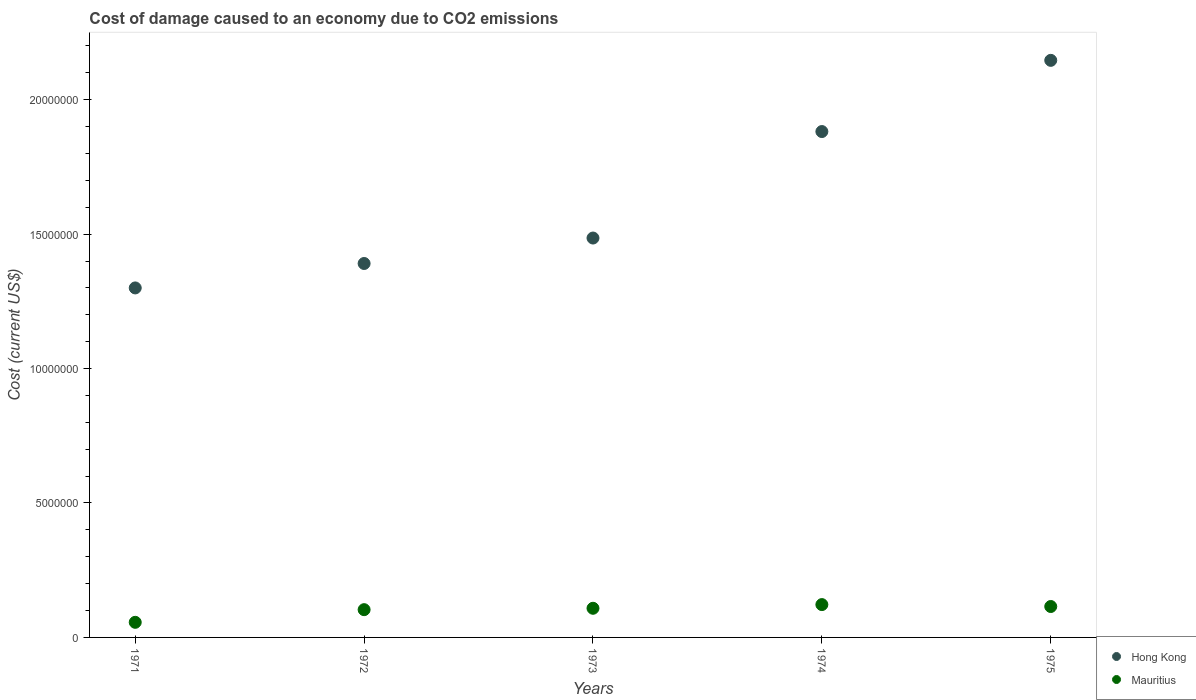Is the number of dotlines equal to the number of legend labels?
Your answer should be very brief. Yes. What is the cost of damage caused due to CO2 emissisons in Mauritius in 1975?
Offer a terse response. 1.15e+06. Across all years, what is the maximum cost of damage caused due to CO2 emissisons in Mauritius?
Make the answer very short. 1.22e+06. Across all years, what is the minimum cost of damage caused due to CO2 emissisons in Mauritius?
Ensure brevity in your answer.  5.62e+05. In which year was the cost of damage caused due to CO2 emissisons in Hong Kong maximum?
Provide a succinct answer. 1975. In which year was the cost of damage caused due to CO2 emissisons in Mauritius minimum?
Ensure brevity in your answer.  1971. What is the total cost of damage caused due to CO2 emissisons in Mauritius in the graph?
Your answer should be very brief. 5.05e+06. What is the difference between the cost of damage caused due to CO2 emissisons in Mauritius in 1973 and that in 1975?
Your answer should be compact. -6.59e+04. What is the difference between the cost of damage caused due to CO2 emissisons in Hong Kong in 1975 and the cost of damage caused due to CO2 emissisons in Mauritius in 1974?
Provide a succinct answer. 2.02e+07. What is the average cost of damage caused due to CO2 emissisons in Mauritius per year?
Your answer should be very brief. 1.01e+06. In the year 1972, what is the difference between the cost of damage caused due to CO2 emissisons in Hong Kong and cost of damage caused due to CO2 emissisons in Mauritius?
Your answer should be compact. 1.29e+07. What is the ratio of the cost of damage caused due to CO2 emissisons in Hong Kong in 1971 to that in 1972?
Give a very brief answer. 0.93. Is the cost of damage caused due to CO2 emissisons in Mauritius in 1972 less than that in 1973?
Ensure brevity in your answer.  Yes. What is the difference between the highest and the second highest cost of damage caused due to CO2 emissisons in Mauritius?
Ensure brevity in your answer.  7.12e+04. What is the difference between the highest and the lowest cost of damage caused due to CO2 emissisons in Mauritius?
Provide a succinct answer. 6.59e+05. Is the sum of the cost of damage caused due to CO2 emissisons in Hong Kong in 1972 and 1974 greater than the maximum cost of damage caused due to CO2 emissisons in Mauritius across all years?
Your response must be concise. Yes. Does the cost of damage caused due to CO2 emissisons in Mauritius monotonically increase over the years?
Your answer should be very brief. No. Is the cost of damage caused due to CO2 emissisons in Hong Kong strictly greater than the cost of damage caused due to CO2 emissisons in Mauritius over the years?
Provide a succinct answer. Yes. How many dotlines are there?
Keep it short and to the point. 2. What is the difference between two consecutive major ticks on the Y-axis?
Provide a short and direct response. 5.00e+06. Are the values on the major ticks of Y-axis written in scientific E-notation?
Offer a very short reply. No. Does the graph contain grids?
Your answer should be compact. No. Where does the legend appear in the graph?
Keep it short and to the point. Bottom right. How many legend labels are there?
Provide a short and direct response. 2. What is the title of the graph?
Offer a very short reply. Cost of damage caused to an economy due to CO2 emissions. Does "Australia" appear as one of the legend labels in the graph?
Provide a succinct answer. No. What is the label or title of the Y-axis?
Offer a terse response. Cost (current US$). What is the Cost (current US$) of Hong Kong in 1971?
Offer a terse response. 1.30e+07. What is the Cost (current US$) in Mauritius in 1971?
Ensure brevity in your answer.  5.62e+05. What is the Cost (current US$) of Hong Kong in 1972?
Keep it short and to the point. 1.39e+07. What is the Cost (current US$) in Mauritius in 1972?
Offer a terse response. 1.03e+06. What is the Cost (current US$) in Hong Kong in 1973?
Keep it short and to the point. 1.49e+07. What is the Cost (current US$) of Mauritius in 1973?
Make the answer very short. 1.08e+06. What is the Cost (current US$) of Hong Kong in 1974?
Ensure brevity in your answer.  1.88e+07. What is the Cost (current US$) of Mauritius in 1974?
Ensure brevity in your answer.  1.22e+06. What is the Cost (current US$) of Hong Kong in 1975?
Your answer should be very brief. 2.15e+07. What is the Cost (current US$) in Mauritius in 1975?
Offer a terse response. 1.15e+06. Across all years, what is the maximum Cost (current US$) of Hong Kong?
Offer a very short reply. 2.15e+07. Across all years, what is the maximum Cost (current US$) in Mauritius?
Your response must be concise. 1.22e+06. Across all years, what is the minimum Cost (current US$) of Hong Kong?
Provide a short and direct response. 1.30e+07. Across all years, what is the minimum Cost (current US$) in Mauritius?
Keep it short and to the point. 5.62e+05. What is the total Cost (current US$) of Hong Kong in the graph?
Your response must be concise. 8.20e+07. What is the total Cost (current US$) in Mauritius in the graph?
Offer a terse response. 5.05e+06. What is the difference between the Cost (current US$) of Hong Kong in 1971 and that in 1972?
Give a very brief answer. -9.09e+05. What is the difference between the Cost (current US$) in Mauritius in 1971 and that in 1972?
Your answer should be very brief. -4.71e+05. What is the difference between the Cost (current US$) of Hong Kong in 1971 and that in 1973?
Make the answer very short. -1.86e+06. What is the difference between the Cost (current US$) in Mauritius in 1971 and that in 1973?
Your response must be concise. -5.22e+05. What is the difference between the Cost (current US$) in Hong Kong in 1971 and that in 1974?
Provide a short and direct response. -5.82e+06. What is the difference between the Cost (current US$) of Mauritius in 1971 and that in 1974?
Offer a terse response. -6.59e+05. What is the difference between the Cost (current US$) of Hong Kong in 1971 and that in 1975?
Offer a very short reply. -8.46e+06. What is the difference between the Cost (current US$) of Mauritius in 1971 and that in 1975?
Keep it short and to the point. -5.88e+05. What is the difference between the Cost (current US$) of Hong Kong in 1972 and that in 1973?
Your answer should be very brief. -9.47e+05. What is the difference between the Cost (current US$) in Mauritius in 1972 and that in 1973?
Offer a terse response. -5.14e+04. What is the difference between the Cost (current US$) of Hong Kong in 1972 and that in 1974?
Your answer should be very brief. -4.91e+06. What is the difference between the Cost (current US$) of Mauritius in 1972 and that in 1974?
Provide a short and direct response. -1.89e+05. What is the difference between the Cost (current US$) of Hong Kong in 1972 and that in 1975?
Provide a succinct answer. -7.56e+06. What is the difference between the Cost (current US$) of Mauritius in 1972 and that in 1975?
Offer a very short reply. -1.17e+05. What is the difference between the Cost (current US$) of Hong Kong in 1973 and that in 1974?
Provide a short and direct response. -3.96e+06. What is the difference between the Cost (current US$) of Mauritius in 1973 and that in 1974?
Offer a very short reply. -1.37e+05. What is the difference between the Cost (current US$) in Hong Kong in 1973 and that in 1975?
Give a very brief answer. -6.61e+06. What is the difference between the Cost (current US$) in Mauritius in 1973 and that in 1975?
Your answer should be very brief. -6.59e+04. What is the difference between the Cost (current US$) of Hong Kong in 1974 and that in 1975?
Keep it short and to the point. -2.65e+06. What is the difference between the Cost (current US$) of Mauritius in 1974 and that in 1975?
Keep it short and to the point. 7.12e+04. What is the difference between the Cost (current US$) of Hong Kong in 1971 and the Cost (current US$) of Mauritius in 1972?
Offer a terse response. 1.20e+07. What is the difference between the Cost (current US$) of Hong Kong in 1971 and the Cost (current US$) of Mauritius in 1973?
Provide a short and direct response. 1.19e+07. What is the difference between the Cost (current US$) in Hong Kong in 1971 and the Cost (current US$) in Mauritius in 1974?
Your answer should be compact. 1.18e+07. What is the difference between the Cost (current US$) of Hong Kong in 1971 and the Cost (current US$) of Mauritius in 1975?
Keep it short and to the point. 1.18e+07. What is the difference between the Cost (current US$) of Hong Kong in 1972 and the Cost (current US$) of Mauritius in 1973?
Keep it short and to the point. 1.28e+07. What is the difference between the Cost (current US$) in Hong Kong in 1972 and the Cost (current US$) in Mauritius in 1974?
Keep it short and to the point. 1.27e+07. What is the difference between the Cost (current US$) of Hong Kong in 1972 and the Cost (current US$) of Mauritius in 1975?
Offer a terse response. 1.28e+07. What is the difference between the Cost (current US$) in Hong Kong in 1973 and the Cost (current US$) in Mauritius in 1974?
Your answer should be compact. 1.36e+07. What is the difference between the Cost (current US$) of Hong Kong in 1973 and the Cost (current US$) of Mauritius in 1975?
Offer a terse response. 1.37e+07. What is the difference between the Cost (current US$) of Hong Kong in 1974 and the Cost (current US$) of Mauritius in 1975?
Offer a very short reply. 1.77e+07. What is the average Cost (current US$) of Hong Kong per year?
Give a very brief answer. 1.64e+07. What is the average Cost (current US$) in Mauritius per year?
Ensure brevity in your answer.  1.01e+06. In the year 1971, what is the difference between the Cost (current US$) in Hong Kong and Cost (current US$) in Mauritius?
Offer a very short reply. 1.24e+07. In the year 1972, what is the difference between the Cost (current US$) of Hong Kong and Cost (current US$) of Mauritius?
Provide a short and direct response. 1.29e+07. In the year 1973, what is the difference between the Cost (current US$) in Hong Kong and Cost (current US$) in Mauritius?
Provide a short and direct response. 1.38e+07. In the year 1974, what is the difference between the Cost (current US$) of Hong Kong and Cost (current US$) of Mauritius?
Ensure brevity in your answer.  1.76e+07. In the year 1975, what is the difference between the Cost (current US$) in Hong Kong and Cost (current US$) in Mauritius?
Give a very brief answer. 2.03e+07. What is the ratio of the Cost (current US$) in Hong Kong in 1971 to that in 1972?
Give a very brief answer. 0.93. What is the ratio of the Cost (current US$) of Mauritius in 1971 to that in 1972?
Provide a short and direct response. 0.54. What is the ratio of the Cost (current US$) in Hong Kong in 1971 to that in 1973?
Give a very brief answer. 0.88. What is the ratio of the Cost (current US$) of Mauritius in 1971 to that in 1973?
Your response must be concise. 0.52. What is the ratio of the Cost (current US$) of Hong Kong in 1971 to that in 1974?
Offer a very short reply. 0.69. What is the ratio of the Cost (current US$) of Mauritius in 1971 to that in 1974?
Offer a terse response. 0.46. What is the ratio of the Cost (current US$) of Hong Kong in 1971 to that in 1975?
Make the answer very short. 0.61. What is the ratio of the Cost (current US$) of Mauritius in 1971 to that in 1975?
Offer a terse response. 0.49. What is the ratio of the Cost (current US$) in Hong Kong in 1972 to that in 1973?
Offer a terse response. 0.94. What is the ratio of the Cost (current US$) of Mauritius in 1972 to that in 1973?
Keep it short and to the point. 0.95. What is the ratio of the Cost (current US$) in Hong Kong in 1972 to that in 1974?
Ensure brevity in your answer.  0.74. What is the ratio of the Cost (current US$) in Mauritius in 1972 to that in 1974?
Offer a very short reply. 0.85. What is the ratio of the Cost (current US$) in Hong Kong in 1972 to that in 1975?
Offer a very short reply. 0.65. What is the ratio of the Cost (current US$) of Mauritius in 1972 to that in 1975?
Offer a terse response. 0.9. What is the ratio of the Cost (current US$) of Hong Kong in 1973 to that in 1974?
Your answer should be compact. 0.79. What is the ratio of the Cost (current US$) of Mauritius in 1973 to that in 1974?
Make the answer very short. 0.89. What is the ratio of the Cost (current US$) in Hong Kong in 1973 to that in 1975?
Your answer should be compact. 0.69. What is the ratio of the Cost (current US$) of Mauritius in 1973 to that in 1975?
Provide a short and direct response. 0.94. What is the ratio of the Cost (current US$) of Hong Kong in 1974 to that in 1975?
Keep it short and to the point. 0.88. What is the ratio of the Cost (current US$) of Mauritius in 1974 to that in 1975?
Provide a short and direct response. 1.06. What is the difference between the highest and the second highest Cost (current US$) in Hong Kong?
Your answer should be very brief. 2.65e+06. What is the difference between the highest and the second highest Cost (current US$) in Mauritius?
Your answer should be compact. 7.12e+04. What is the difference between the highest and the lowest Cost (current US$) in Hong Kong?
Make the answer very short. 8.46e+06. What is the difference between the highest and the lowest Cost (current US$) of Mauritius?
Provide a short and direct response. 6.59e+05. 